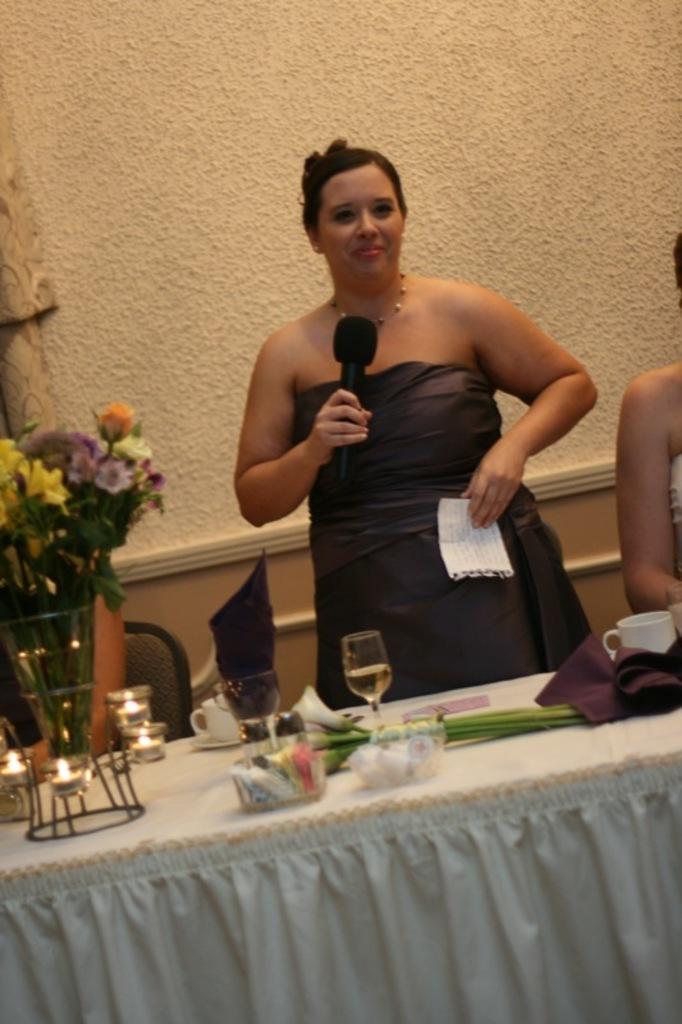In one or two sentences, can you explain what this image depicts? She is standing. She is holding a paper and mic. She is smiling. There is a table. There is a flower vase,cup and saucer,glass,tissue on a table. On the right side we have a woman. She is sitting in a chair. 